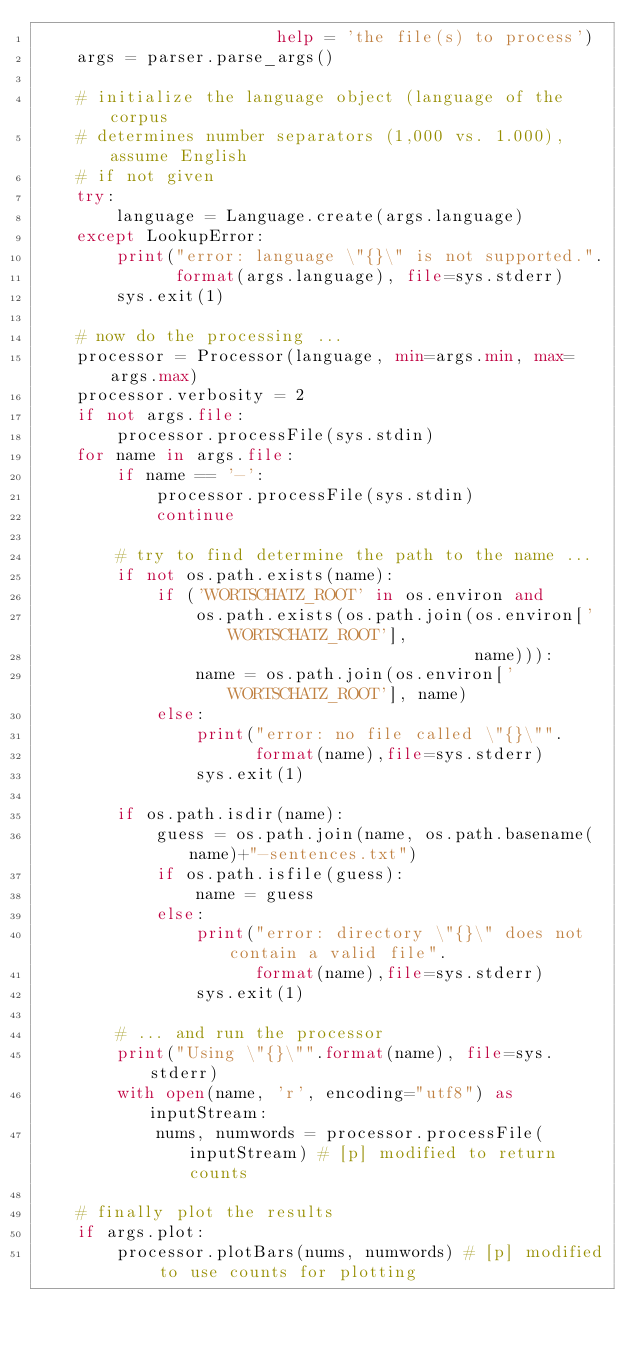Convert code to text. <code><loc_0><loc_0><loc_500><loc_500><_Python_>                        help = 'the file(s) to process')
    args = parser.parse_args()

    # initialize the language object (language of the corpus
    # determines number separators (1,000 vs. 1.000), assume English
    # if not given
    try:
        language = Language.create(args.language)
    except LookupError:
        print("error: language \"{}\" is not supported.".
              format(args.language), file=sys.stderr)
        sys.exit(1)

    # now do the processing ...
    processor = Processor(language, min=args.min, max=args.max)
    processor.verbosity = 2
    if not args.file:
        processor.processFile(sys.stdin)
    for name in args.file:
        if name == '-':
            processor.processFile(sys.stdin)
            continue

        # try to find determine the path to the name ...
        if not os.path.exists(name):
            if ('WORTSCHATZ_ROOT' in os.environ and
                os.path.exists(os.path.join(os.environ['WORTSCHATZ_ROOT'],
                                            name))):
                name = os.path.join(os.environ['WORTSCHATZ_ROOT'], name)
            else:
                print("error: no file called \"{}\"".
                      format(name),file=sys.stderr)
                sys.exit(1)

        if os.path.isdir(name):
            guess = os.path.join(name, os.path.basename(name)+"-sentences.txt")
            if os.path.isfile(guess):
                name = guess
            else:
                print("error: directory \"{}\" does not contain a valid file".
                      format(name),file=sys.stderr)
                sys.exit(1)

        # ... and run the processor
        print("Using \"{}\"".format(name), file=sys.stderr)
        with open(name, 'r', encoding="utf8") as inputStream:
            nums, numwords = processor.processFile(inputStream) # [p] modified to return counts

    # finally plot the results
    if args.plot:
        processor.plotBars(nums, numwords) # [p] modified to use counts for plotting
</code> 